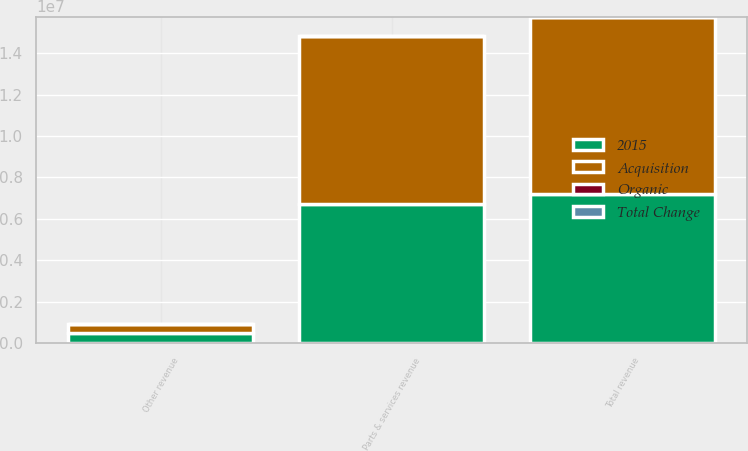<chart> <loc_0><loc_0><loc_500><loc_500><stacked_bar_chart><ecel><fcel>Parts & services revenue<fcel>Other revenue<fcel>Total revenue<nl><fcel>Acquisition<fcel>8.14464e+06<fcel>439386<fcel>8.58403e+06<nl><fcel>2015<fcel>6.71395e+06<fcel>478682<fcel>7.19263e+06<nl><fcel>Organic<fcel>4.8<fcel>11.2<fcel>3.7<nl><fcel>Total Change<fcel>19<fcel>3.1<fcel>18<nl></chart> 